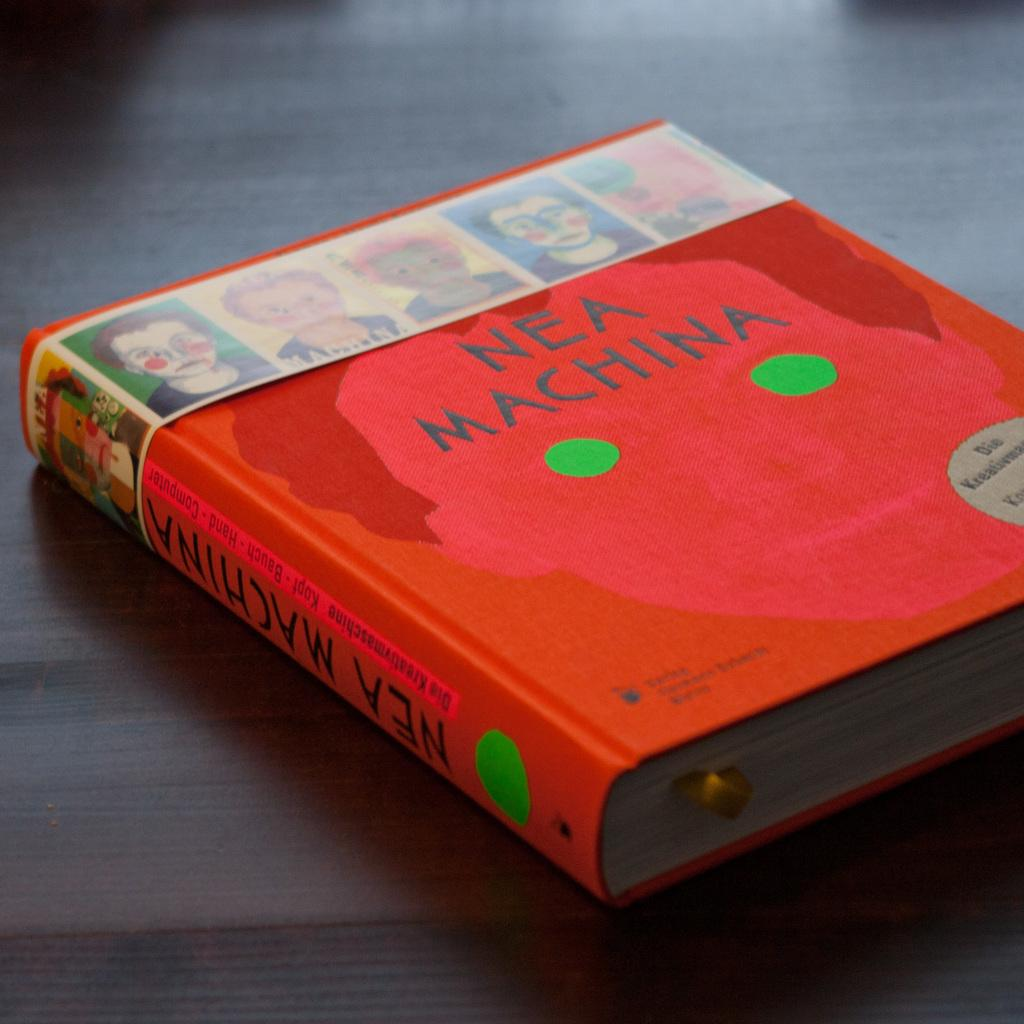<image>
Give a short and clear explanation of the subsequent image. Nea Machina is an interesting read and a good book. 